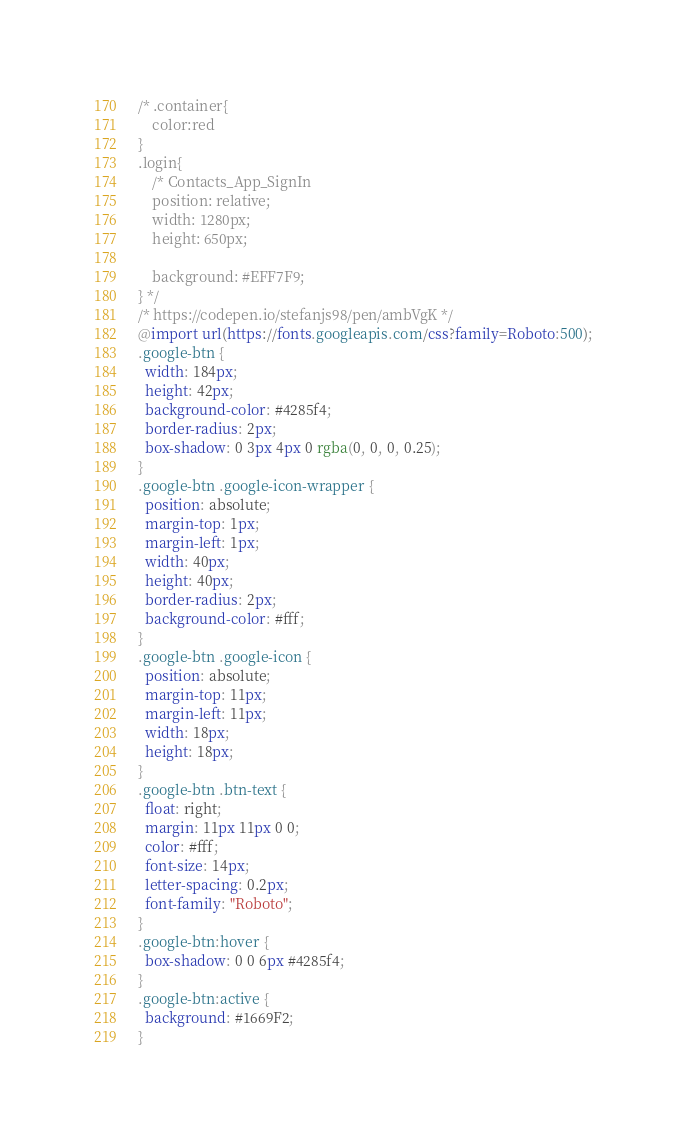<code> <loc_0><loc_0><loc_500><loc_500><_CSS_>/* .container{
    color:red
}
.login{
    /* Contacts_App_SignIn 
    position: relative;
    width: 1280px;
    height: 650px;

    background: #EFF7F9;
} */
/* https://codepen.io/stefanjs98/pen/ambVgK */ 
@import url(https://fonts.googleapis.com/css?family=Roboto:500);
.google-btn {
  width: 184px;
  height: 42px;
  background-color: #4285f4;
  border-radius: 2px;
  box-shadow: 0 3px 4px 0 rgba(0, 0, 0, 0.25);
}
.google-btn .google-icon-wrapper {
  position: absolute;
  margin-top: 1px;
  margin-left: 1px;
  width: 40px;
  height: 40px;
  border-radius: 2px;
  background-color: #fff;
}
.google-btn .google-icon {
  position: absolute;
  margin-top: 11px;
  margin-left: 11px;
  width: 18px;
  height: 18px;
}
.google-btn .btn-text {
  float: right;
  margin: 11px 11px 0 0;
  color: #fff;
  font-size: 14px;
  letter-spacing: 0.2px;
  font-family: "Roboto";
}
.google-btn:hover {
  box-shadow: 0 0 6px #4285f4;
}
.google-btn:active {
  background: #1669F2;
}</code> 